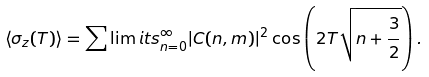Convert formula to latex. <formula><loc_0><loc_0><loc_500><loc_500>\langle \sigma _ { z } ( T ) \rangle = \sum \lim i t s _ { n = 0 } ^ { \infty } | C ( n , m ) | ^ { 2 } \cos \left ( 2 T \sqrt { n + \frac { 3 } { 2 } } \right ) .</formula> 